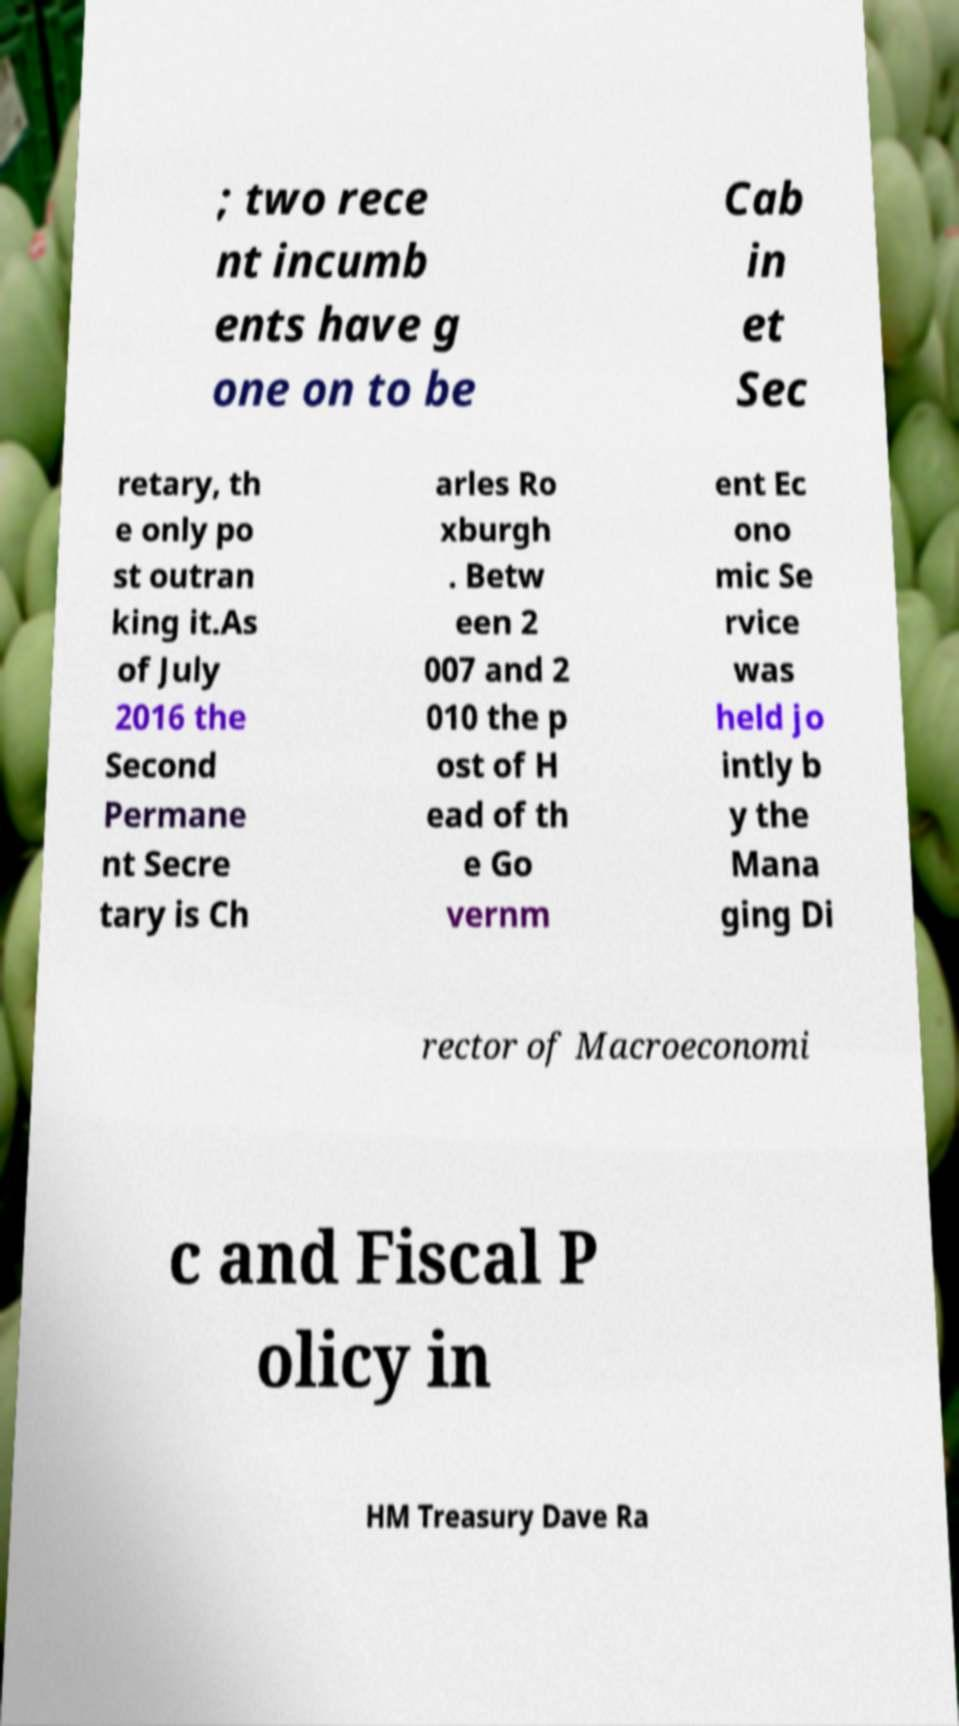There's text embedded in this image that I need extracted. Can you transcribe it verbatim? ; two rece nt incumb ents have g one on to be Cab in et Sec retary, th e only po st outran king it.As of July 2016 the Second Permane nt Secre tary is Ch arles Ro xburgh . Betw een 2 007 and 2 010 the p ost of H ead of th e Go vernm ent Ec ono mic Se rvice was held jo intly b y the Mana ging Di rector of Macroeconomi c and Fiscal P olicy in HM Treasury Dave Ra 